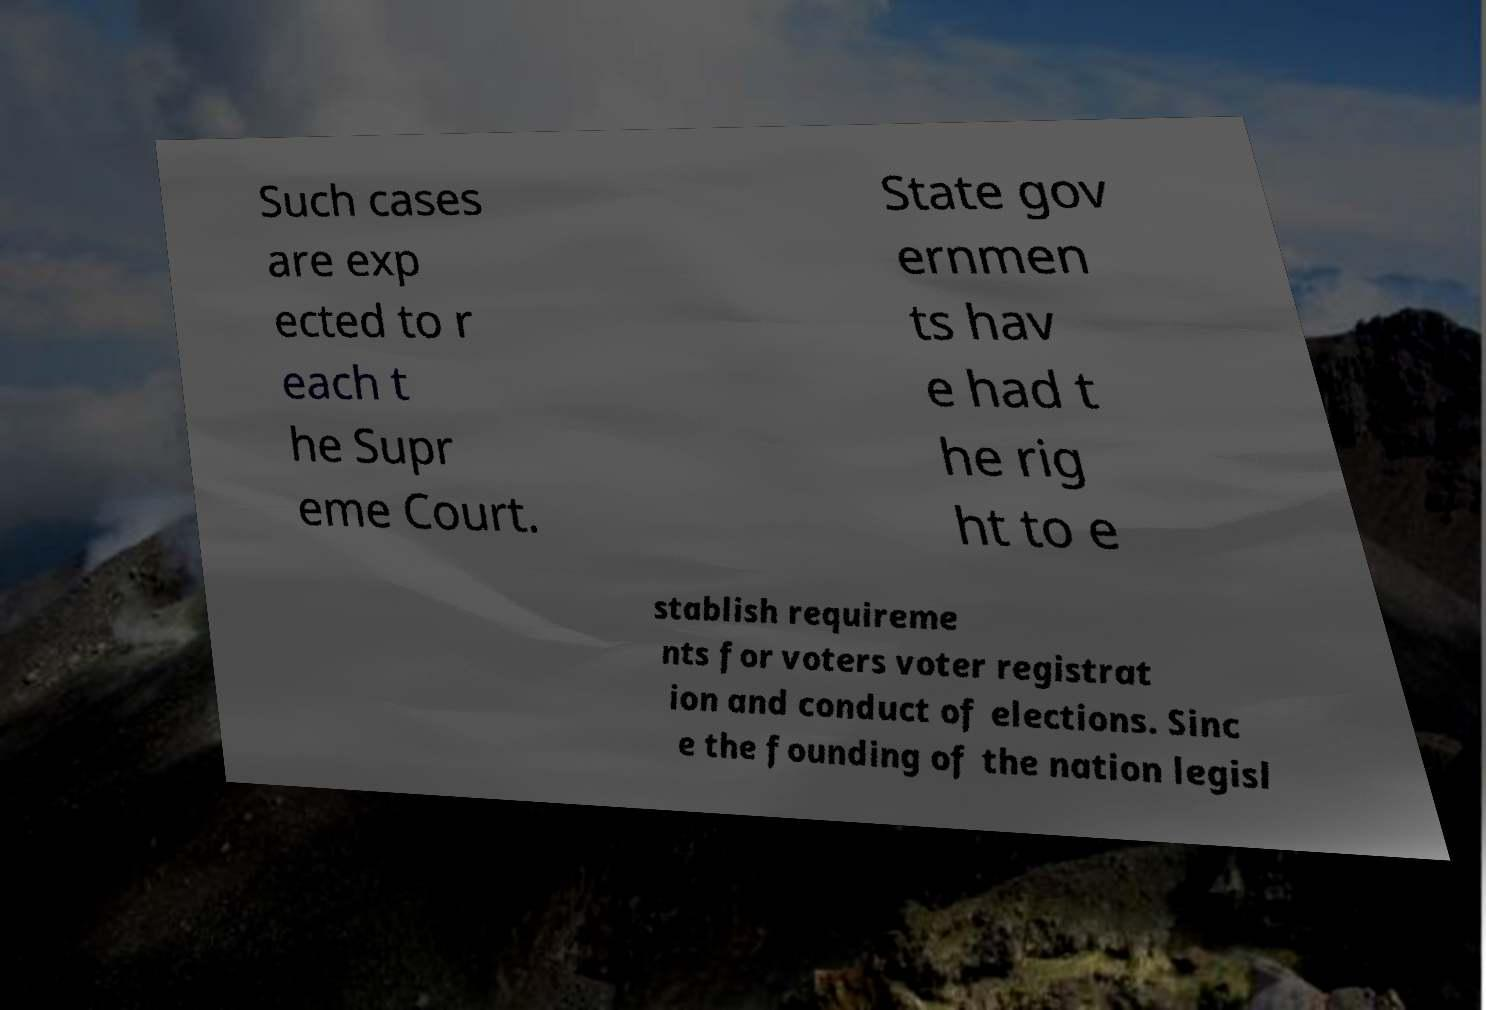Can you read and provide the text displayed in the image?This photo seems to have some interesting text. Can you extract and type it out for me? Such cases are exp ected to r each t he Supr eme Court. State gov ernmen ts hav e had t he rig ht to e stablish requireme nts for voters voter registrat ion and conduct of elections. Sinc e the founding of the nation legisl 